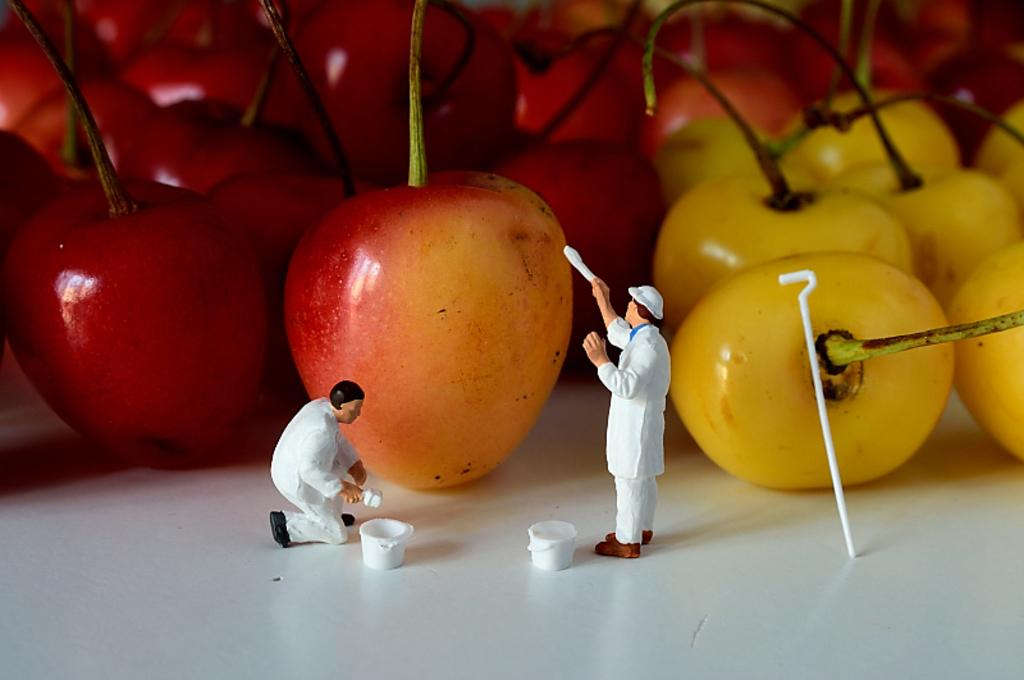What colors are the cherries in the image? The cherries in the image are red and yellow. What is the color of the surface on which the cherries are placed? The cherries are on a white surface. What other items can be seen in the image besides the cherries? There are toys visible in the image. What is the limit of the cherries in the image? There is no limit mentioned for the cherries in the image; they are simply depicted as red and yellow cherries on a white surface. 